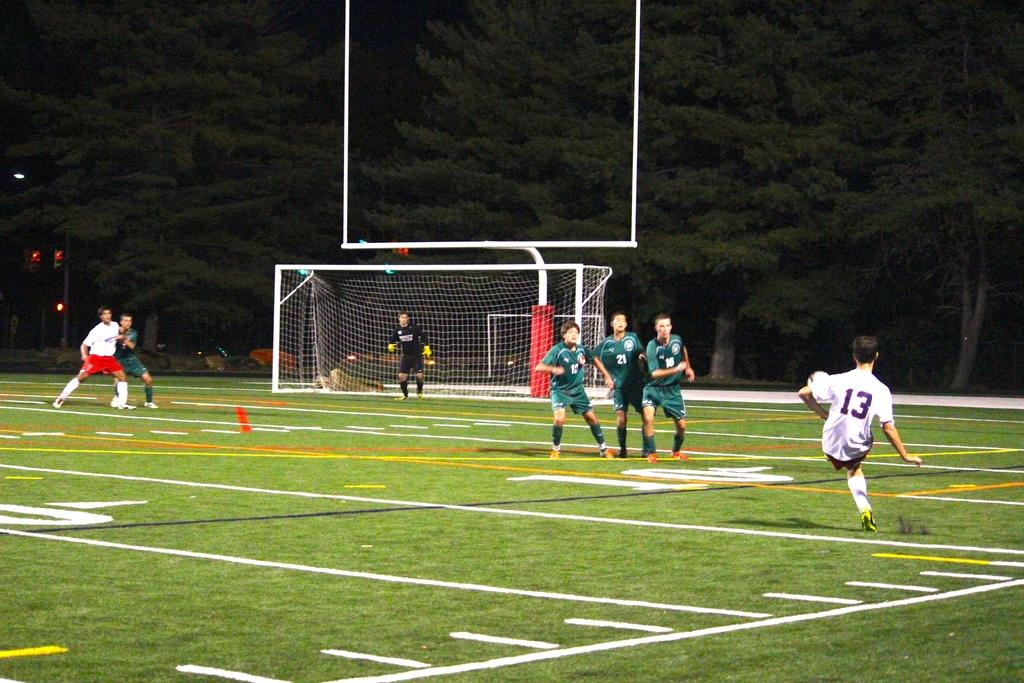<image>
Summarize the visual content of the image. Player number 13 kicks the soccer ball towards players 10 and 21 